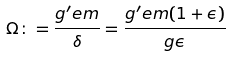<formula> <loc_0><loc_0><loc_500><loc_500>\Omega \colon = \frac { g ^ { \prime } e m } { \delta } = \frac { g ^ { \prime } e m ( 1 + \epsilon ) } { g \epsilon }</formula> 